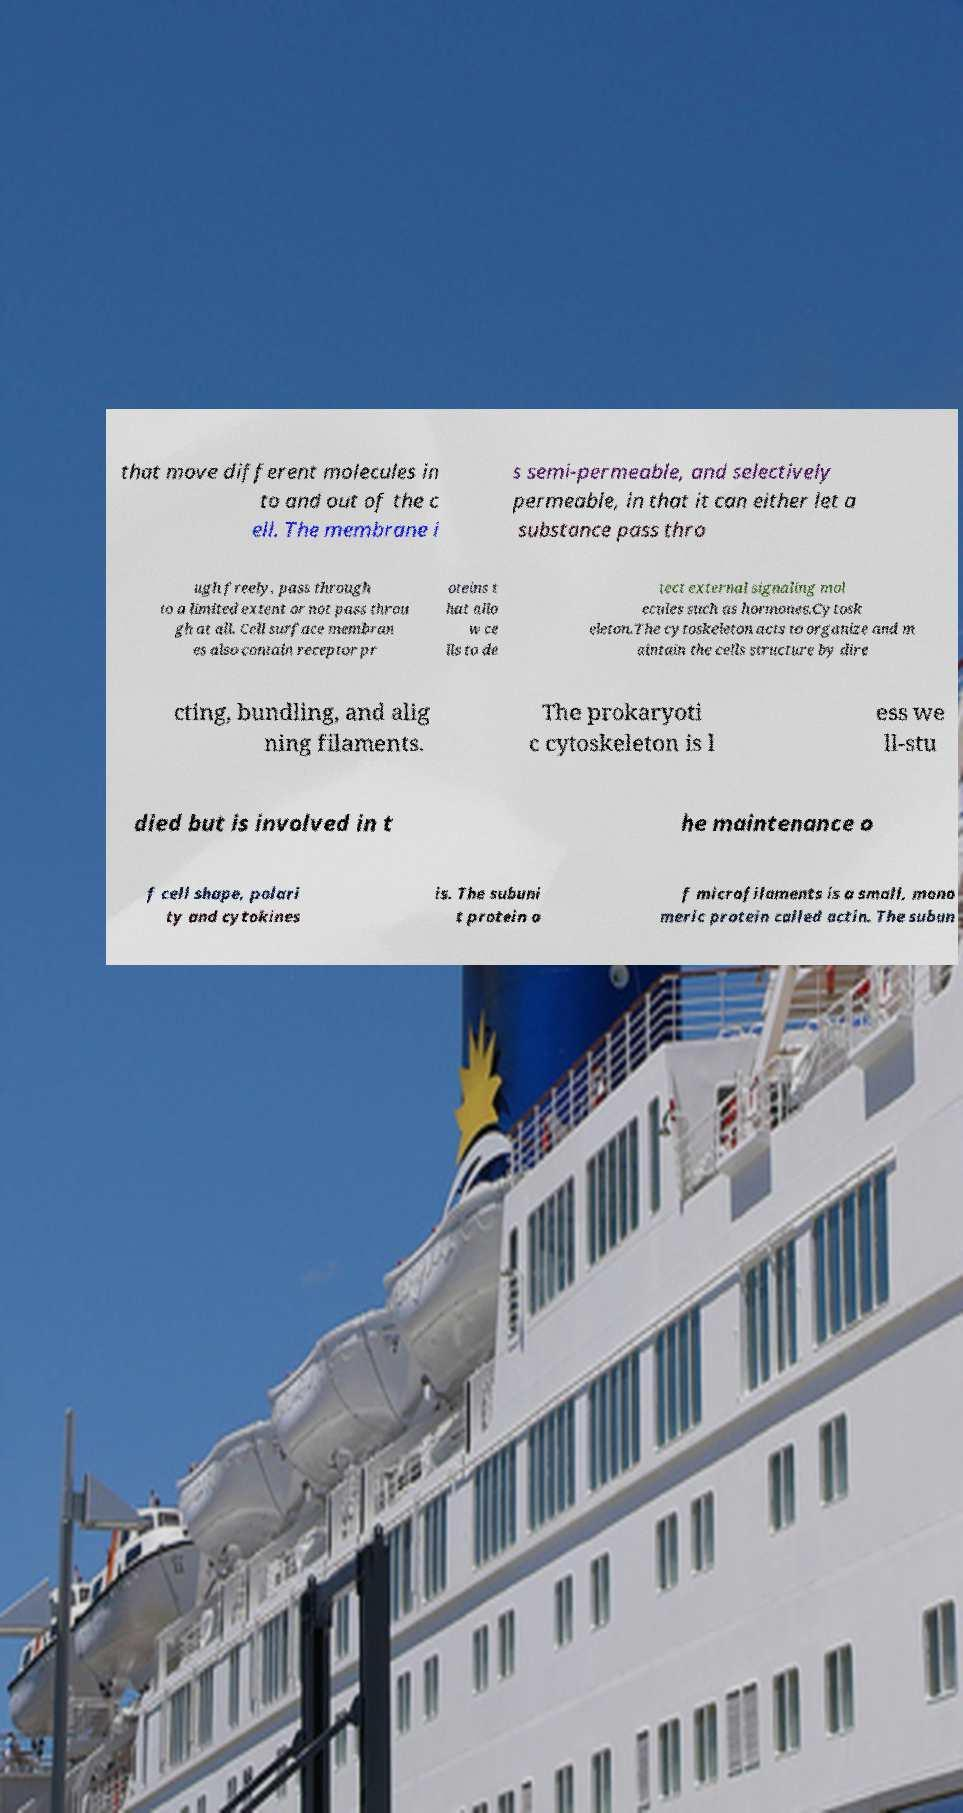Could you extract and type out the text from this image? that move different molecules in to and out of the c ell. The membrane i s semi-permeable, and selectively permeable, in that it can either let a substance pass thro ugh freely, pass through to a limited extent or not pass throu gh at all. Cell surface membran es also contain receptor pr oteins t hat allo w ce lls to de tect external signaling mol ecules such as hormones.Cytosk eleton.The cytoskeleton acts to organize and m aintain the cells structure by dire cting, bundling, and alig ning filaments. The prokaryoti c cytoskeleton is l ess we ll-stu died but is involved in t he maintenance o f cell shape, polari ty and cytokines is. The subuni t protein o f microfilaments is a small, mono meric protein called actin. The subun 